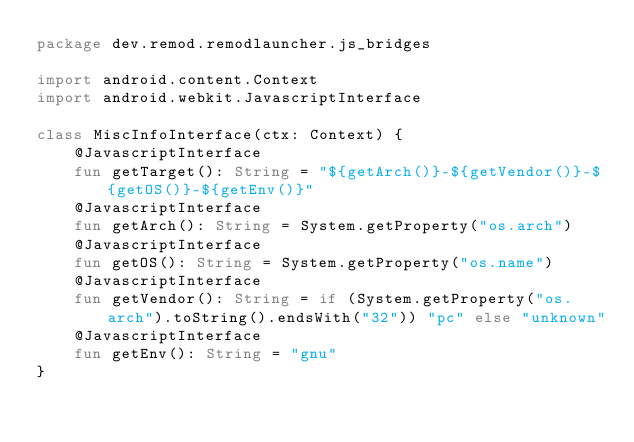<code> <loc_0><loc_0><loc_500><loc_500><_Kotlin_>package dev.remod.remodlauncher.js_bridges

import android.content.Context
import android.webkit.JavascriptInterface

class MiscInfoInterface(ctx: Context) {
    @JavascriptInterface
    fun getTarget(): String = "${getArch()}-${getVendor()}-${getOS()}-${getEnv()}"
    @JavascriptInterface
    fun getArch(): String = System.getProperty("os.arch")
    @JavascriptInterface
    fun getOS(): String = System.getProperty("os.name")
    @JavascriptInterface
    fun getVendor(): String = if (System.getProperty("os.arch").toString().endsWith("32")) "pc" else "unknown"
    @JavascriptInterface
    fun getEnv(): String = "gnu"
}</code> 